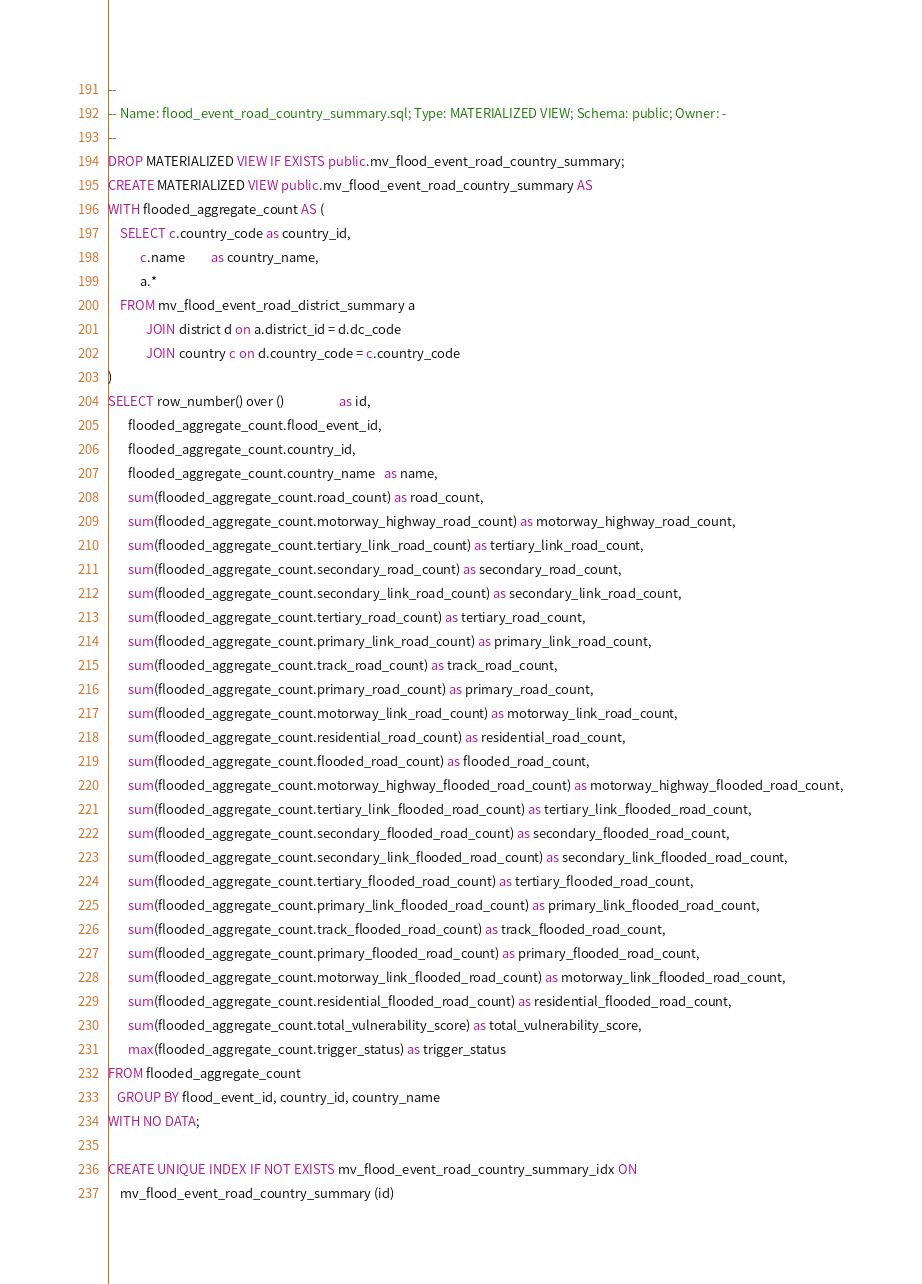Convert code to text. <code><loc_0><loc_0><loc_500><loc_500><_SQL_>--
-- Name: flood_event_road_country_summary.sql; Type: MATERIALIZED VIEW; Schema: public; Owner: -
--
DROP MATERIALIZED VIEW IF EXISTS public.mv_flood_event_road_country_summary;
CREATE MATERIALIZED VIEW public.mv_flood_event_road_country_summary AS
WITH flooded_aggregate_count AS (
    SELECT c.country_code as country_id,
           c.name         as country_name,
           a.*
    FROM mv_flood_event_road_district_summary a
             JOIN district d on a.district_id = d.dc_code
             JOIN country c on d.country_code = c.country_code
)
SELECT row_number() over ()                   as id,
       flooded_aggregate_count.flood_event_id,
       flooded_aggregate_count.country_id,
       flooded_aggregate_count.country_name   as name,
       sum(flooded_aggregate_count.road_count) as road_count,
       sum(flooded_aggregate_count.motorway_highway_road_count) as motorway_highway_road_count,
       sum(flooded_aggregate_count.tertiary_link_road_count) as tertiary_link_road_count,
       sum(flooded_aggregate_count.secondary_road_count) as secondary_road_count,
       sum(flooded_aggregate_count.secondary_link_road_count) as secondary_link_road_count,
       sum(flooded_aggregate_count.tertiary_road_count) as tertiary_road_count,
       sum(flooded_aggregate_count.primary_link_road_count) as primary_link_road_count,
       sum(flooded_aggregate_count.track_road_count) as track_road_count,
       sum(flooded_aggregate_count.primary_road_count) as primary_road_count,
       sum(flooded_aggregate_count.motorway_link_road_count) as motorway_link_road_count,
       sum(flooded_aggregate_count.residential_road_count) as residential_road_count,
       sum(flooded_aggregate_count.flooded_road_count) as flooded_road_count,
       sum(flooded_aggregate_count.motorway_highway_flooded_road_count) as motorway_highway_flooded_road_count,
       sum(flooded_aggregate_count.tertiary_link_flooded_road_count) as tertiary_link_flooded_road_count,
       sum(flooded_aggregate_count.secondary_flooded_road_count) as secondary_flooded_road_count,
       sum(flooded_aggregate_count.secondary_link_flooded_road_count) as secondary_link_flooded_road_count,
       sum(flooded_aggregate_count.tertiary_flooded_road_count) as tertiary_flooded_road_count,
       sum(flooded_aggregate_count.primary_link_flooded_road_count) as primary_link_flooded_road_count,
       sum(flooded_aggregate_count.track_flooded_road_count) as track_flooded_road_count,
       sum(flooded_aggregate_count.primary_flooded_road_count) as primary_flooded_road_count,
       sum(flooded_aggregate_count.motorway_link_flooded_road_count) as motorway_link_flooded_road_count,
       sum(flooded_aggregate_count.residential_flooded_road_count) as residential_flooded_road_count,
       sum(flooded_aggregate_count.total_vulnerability_score) as total_vulnerability_score,
       max(flooded_aggregate_count.trigger_status) as trigger_status
FROM flooded_aggregate_count
   GROUP BY flood_event_id, country_id, country_name
WITH NO DATA;

CREATE UNIQUE INDEX IF NOT EXISTS mv_flood_event_road_country_summary_idx ON
    mv_flood_event_road_country_summary (id)
</code> 